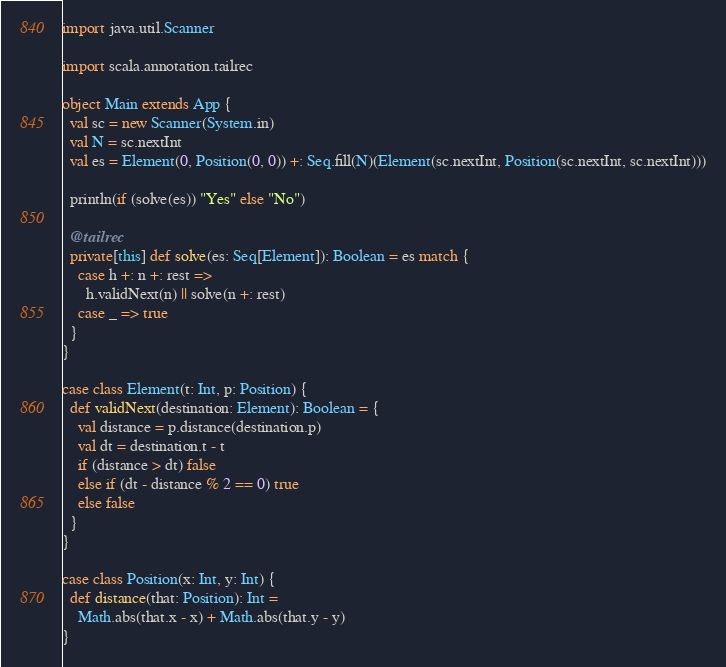<code> <loc_0><loc_0><loc_500><loc_500><_Scala_>import java.util.Scanner

import scala.annotation.tailrec

object Main extends App {
  val sc = new Scanner(System.in)
  val N = sc.nextInt
  val es = Element(0, Position(0, 0)) +: Seq.fill(N)(Element(sc.nextInt, Position(sc.nextInt, sc.nextInt)))

  println(if (solve(es)) "Yes" else "No")

  @tailrec
  private[this] def solve(es: Seq[Element]): Boolean = es match {
    case h +: n +: rest =>
      h.validNext(n) || solve(n +: rest)
    case _ => true
  }
}

case class Element(t: Int, p: Position) {
  def validNext(destination: Element): Boolean = {
    val distance = p.distance(destination.p)
    val dt = destination.t - t
    if (distance > dt) false
    else if (dt - distance % 2 == 0) true
    else false
  }
}

case class Position(x: Int, y: Int) {
  def distance(that: Position): Int =
    Math.abs(that.x - x) + Math.abs(that.y - y)
}
</code> 